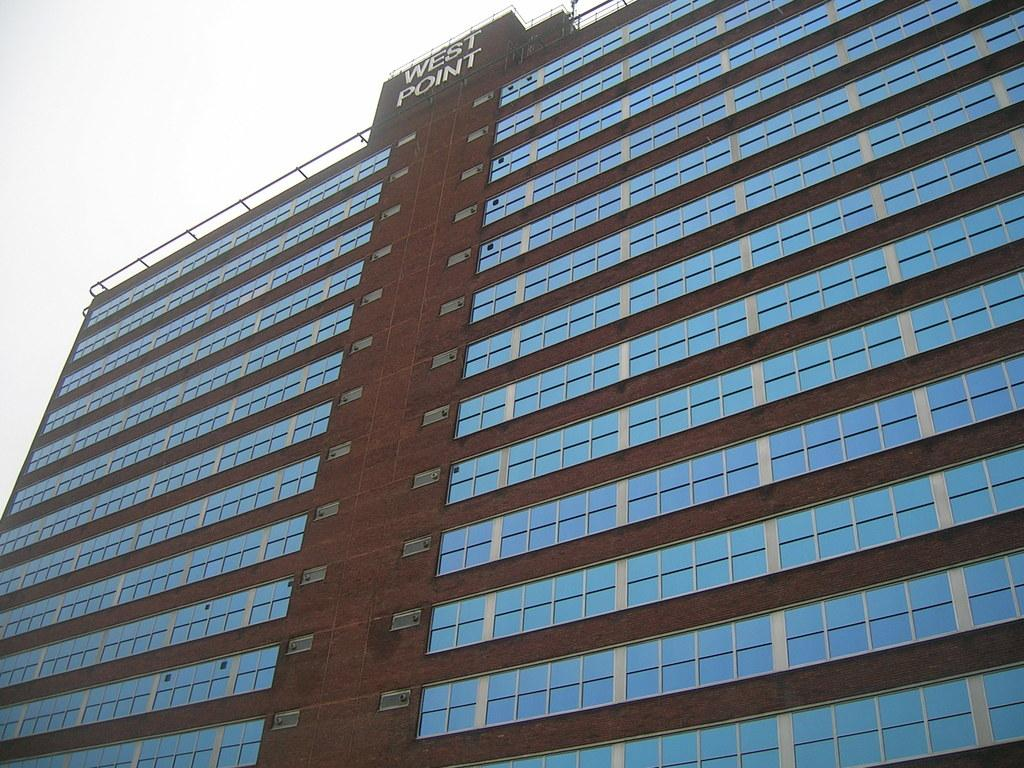What is the main structure visible in the image? There is a building in the image. What feature can be seen on the building? The building has windows. Is there any text visible on the building? Yes, there is text written at the top of the building. What type of dog can be seen walking in the direction of the building in the image? There is no dog present in the image, nor is there any indication of a direction. 